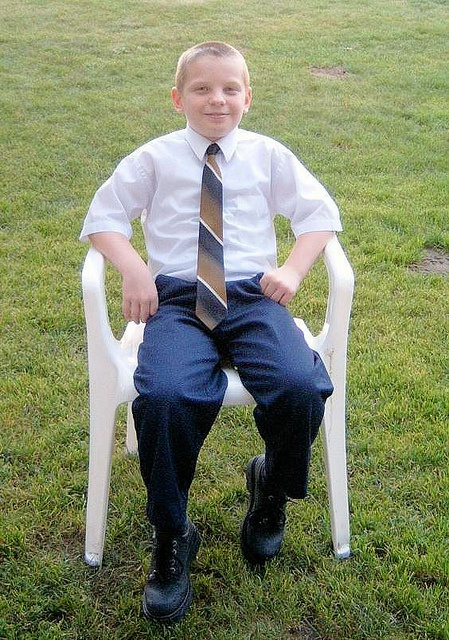Describe the objects in this image and their specific colors. I can see people in tan, black, lavender, gray, and navy tones, chair in tan, lightgray, darkgray, olive, and gray tones, and tie in tan and gray tones in this image. 